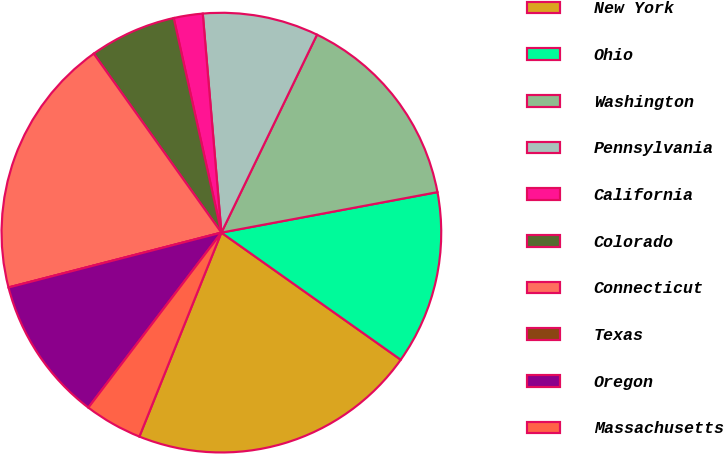Convert chart. <chart><loc_0><loc_0><loc_500><loc_500><pie_chart><fcel>New York<fcel>Ohio<fcel>Washington<fcel>Pennsylvania<fcel>California<fcel>Colorado<fcel>Connecticut<fcel>Texas<fcel>Oregon<fcel>Massachusetts<nl><fcel>21.27%<fcel>12.76%<fcel>14.89%<fcel>8.51%<fcel>2.13%<fcel>6.38%<fcel>19.15%<fcel>0.0%<fcel>10.64%<fcel>4.26%<nl></chart> 